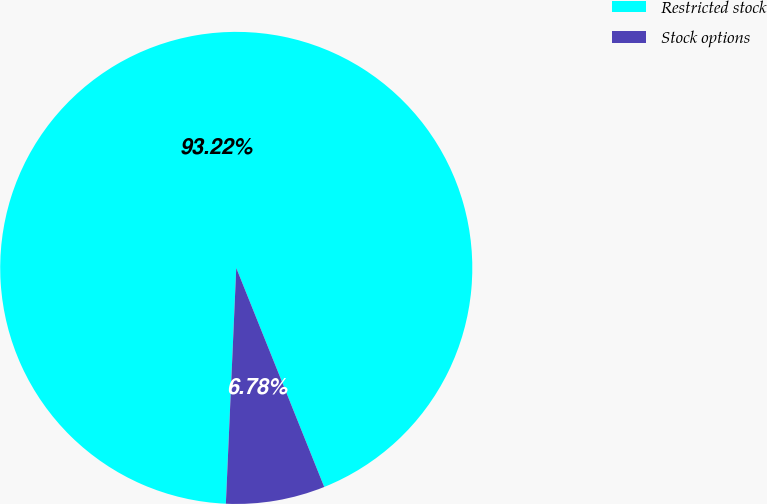<chart> <loc_0><loc_0><loc_500><loc_500><pie_chart><fcel>Restricted stock<fcel>Stock options<nl><fcel>93.22%<fcel>6.78%<nl></chart> 